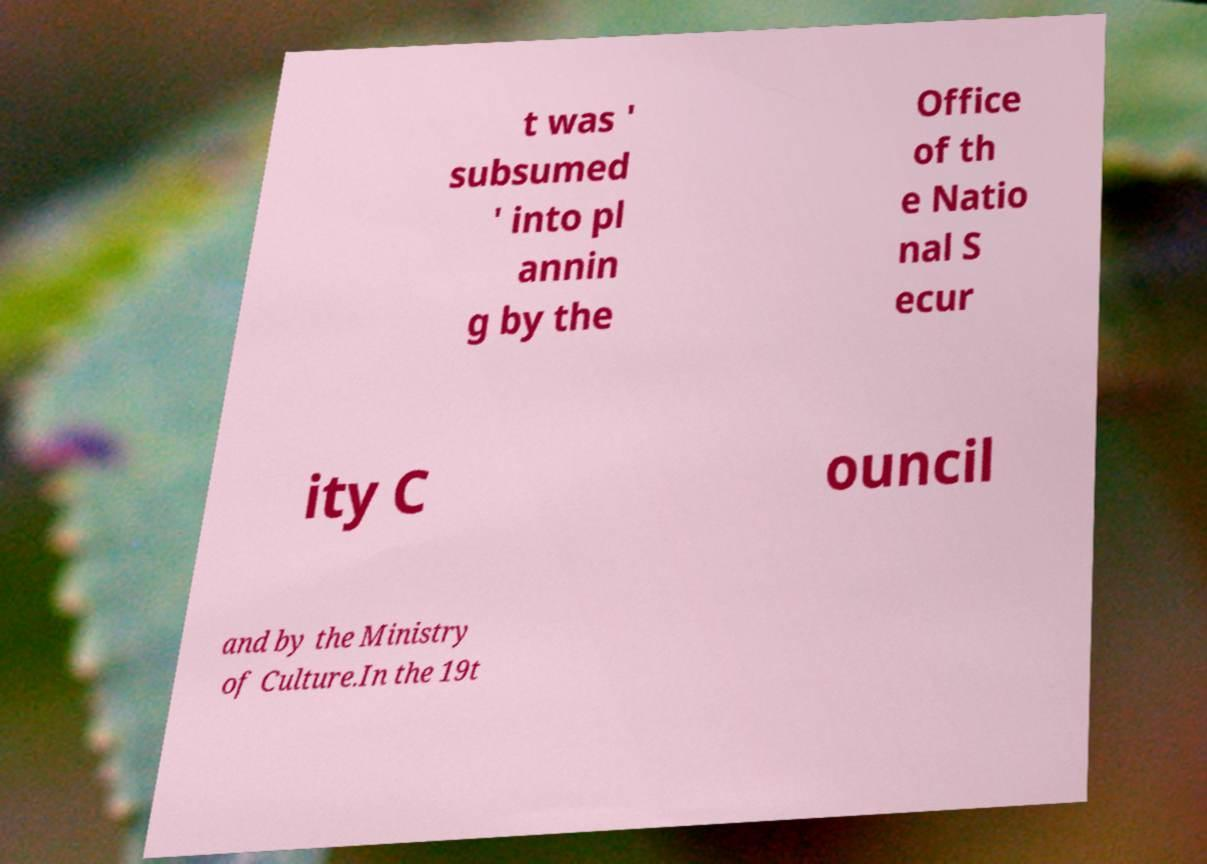For documentation purposes, I need the text within this image transcribed. Could you provide that? t was ' subsumed ' into pl annin g by the Office of th e Natio nal S ecur ity C ouncil and by the Ministry of Culture.In the 19t 